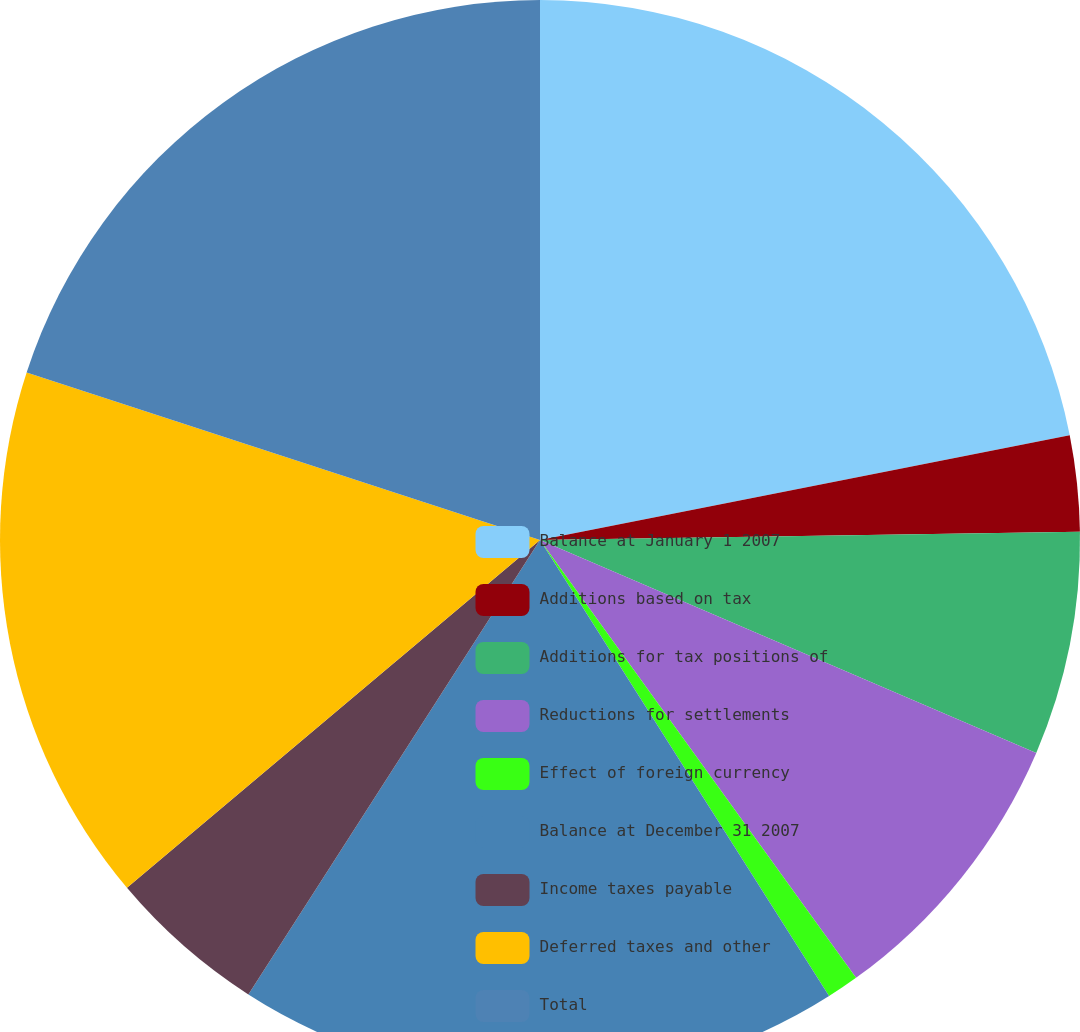Convert chart. <chart><loc_0><loc_0><loc_500><loc_500><pie_chart><fcel>Balance at January 1 2007<fcel>Additions based on tax<fcel>Additions for tax positions of<fcel>Reductions for settlements<fcel>Effect of foreign currency<fcel>Balance at December 31 2007<fcel>Income taxes payable<fcel>Deferred taxes and other<fcel>Total<nl><fcel>21.89%<fcel>2.87%<fcel>6.69%<fcel>8.6%<fcel>0.96%<fcel>18.07%<fcel>4.78%<fcel>16.16%<fcel>19.98%<nl></chart> 